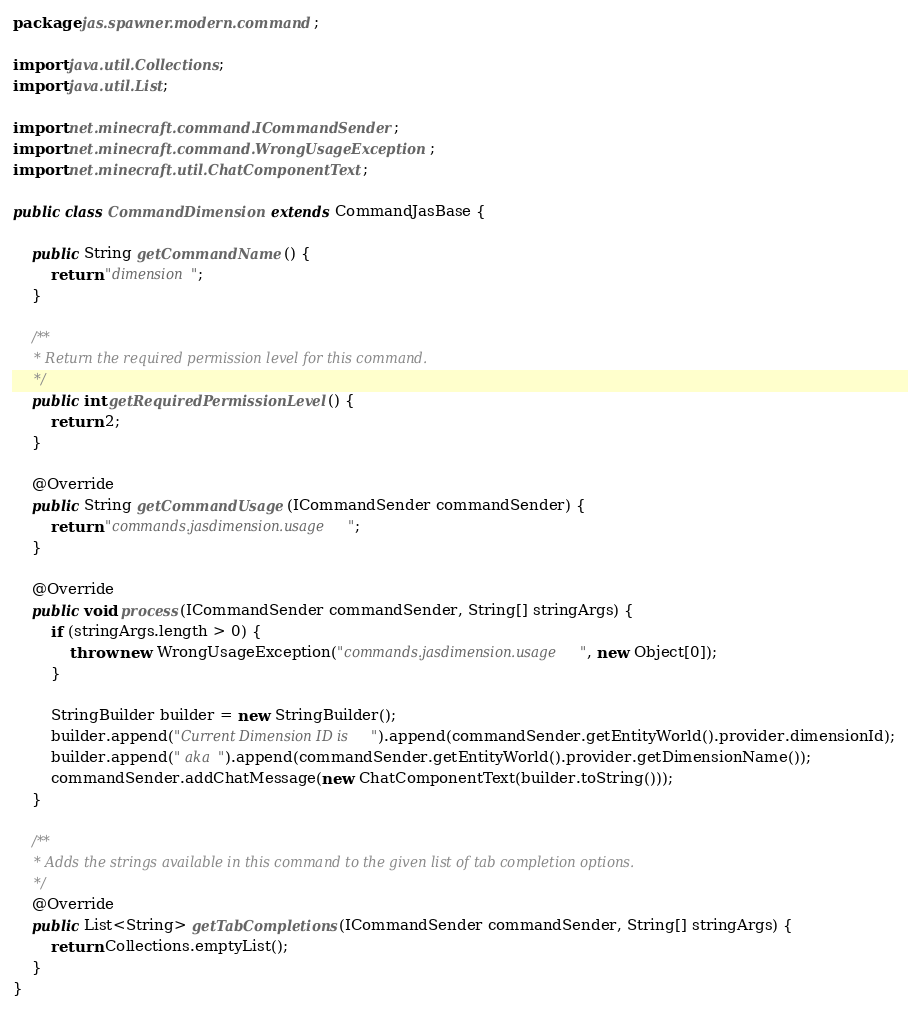Convert code to text. <code><loc_0><loc_0><loc_500><loc_500><_Java_>package jas.spawner.modern.command;

import java.util.Collections;
import java.util.List;

import net.minecraft.command.ICommandSender;
import net.minecraft.command.WrongUsageException;
import net.minecraft.util.ChatComponentText;

public class CommandDimension extends CommandJasBase {

	public String getCommandName() {
		return "dimension";
	}

	/**
	 * Return the required permission level for this command.
	 */
	public int getRequiredPermissionLevel() {
		return 2;
	}

	@Override
	public String getCommandUsage(ICommandSender commandSender) {
		return "commands.jasdimension.usage";
	}

	@Override
	public void process(ICommandSender commandSender, String[] stringArgs) {
		if (stringArgs.length > 0) {
			throw new WrongUsageException("commands.jasdimension.usage", new Object[0]);
		}

		StringBuilder builder = new StringBuilder();
		builder.append("Current Dimension ID is ").append(commandSender.getEntityWorld().provider.dimensionId);
		builder.append(" aka ").append(commandSender.getEntityWorld().provider.getDimensionName());
		commandSender.addChatMessage(new ChatComponentText(builder.toString()));
	}

	/**
	 * Adds the strings available in this command to the given list of tab completion options.
	 */
	@Override
	public List<String> getTabCompletions(ICommandSender commandSender, String[] stringArgs) {
		return Collections.emptyList();
	}
}
</code> 